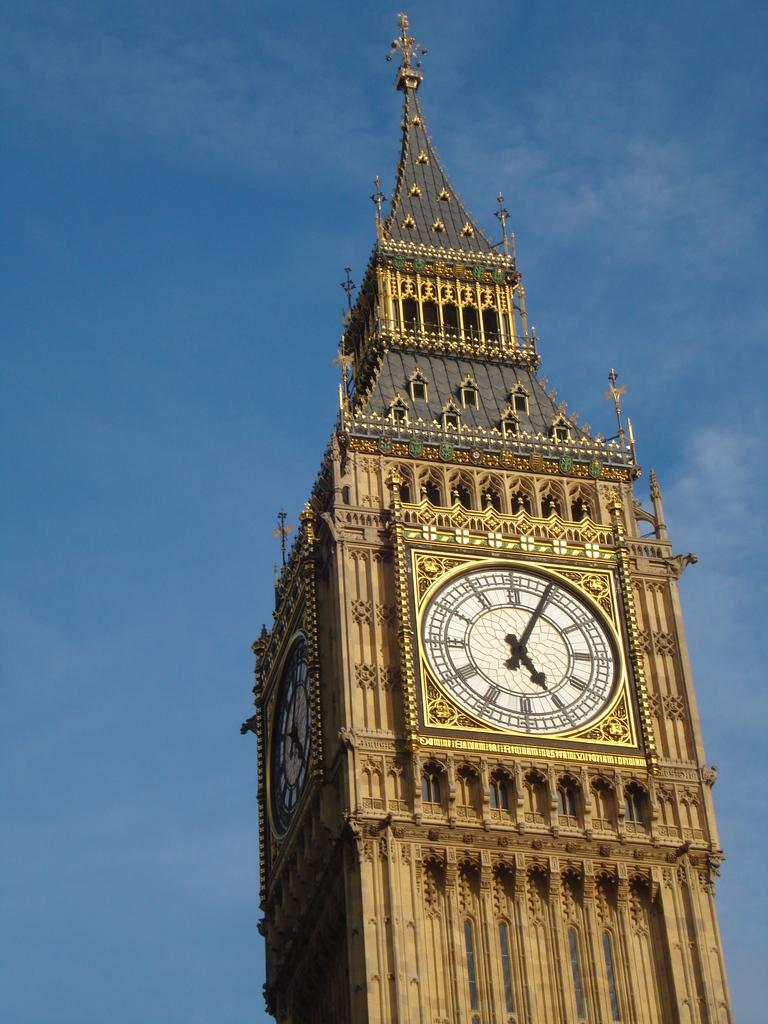What is the main structure in the picture? There is a clock tower in the picture. What can be seen in the background of the picture? The sky is visible in the background of the picture. What is the color of the sky in the picture? The color of the sky is blue. How many deer can be seen grazing near the clock tower in the image? There are no deer present in the image; it only features a clock tower and the blue sky. What type of insect is flying around the clock tower in the image? There are no insects visible in the image; it only features a clock tower and the blue sky. 